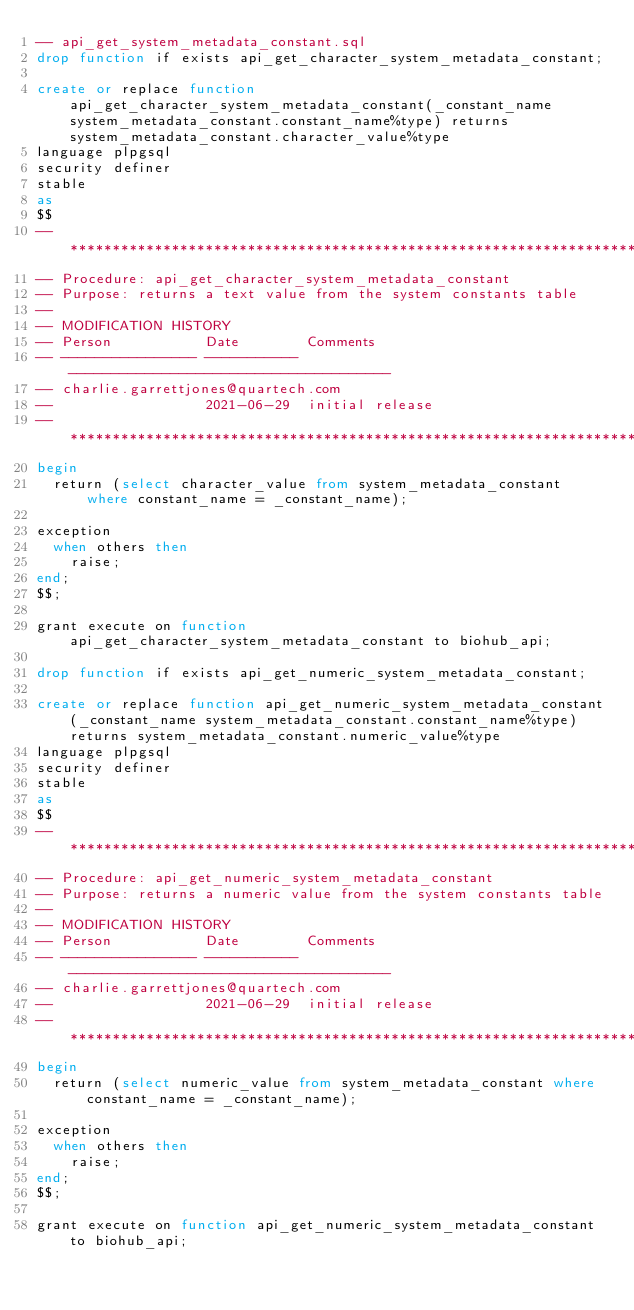<code> <loc_0><loc_0><loc_500><loc_500><_SQL_>-- api_get_system_metadata_constant.sql
drop function if exists api_get_character_system_metadata_constant;

create or replace function api_get_character_system_metadata_constant(_constant_name system_metadata_constant.constant_name%type) returns system_metadata_constant.character_value%type
language plpgsql
security definer
stable
as
$$
-- *******************************************************************
-- Procedure: api_get_character_system_metadata_constant
-- Purpose: returns a text value from the system constants table
--
-- MODIFICATION HISTORY
-- Person           Date        Comments
-- ---------------- ----------- --------------------------------------
-- charlie.garrettjones@quartech.com
--                  2021-06-29  initial release
-- *******************************************************************
begin
  return (select character_value from system_metadata_constant where constant_name = _constant_name);

exception
  when others then
    raise;
end;
$$;

grant execute on function api_get_character_system_metadata_constant to biohub_api;

drop function if exists api_get_numeric_system_metadata_constant;

create or replace function api_get_numeric_system_metadata_constant(_constant_name system_metadata_constant.constant_name%type) returns system_metadata_constant.numeric_value%type
language plpgsql
security definer
stable
as
$$
-- *******************************************************************
-- Procedure: api_get_numeric_system_metadata_constant
-- Purpose: returns a numeric value from the system constants table
--
-- MODIFICATION HISTORY
-- Person           Date        Comments
-- ---------------- ----------- --------------------------------------
-- charlie.garrettjones@quartech.com
--                  2021-06-29  initial release
-- *******************************************************************
begin
  return (select numeric_value from system_metadata_constant where constant_name = _constant_name);

exception
  when others then
    raise;
end;
$$;

grant execute on function api_get_numeric_system_metadata_constant to biohub_api;
</code> 